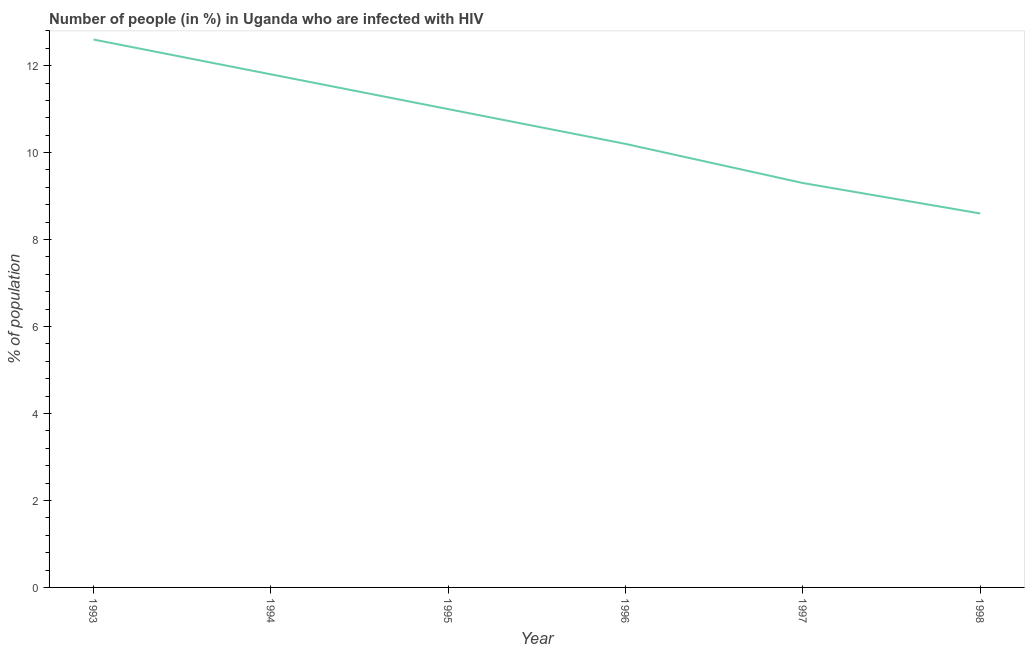What is the number of people infected with hiv in 1993?
Provide a succinct answer. 12.6. In which year was the number of people infected with hiv minimum?
Your response must be concise. 1998. What is the sum of the number of people infected with hiv?
Your answer should be very brief. 63.5. What is the average number of people infected with hiv per year?
Give a very brief answer. 10.58. In how many years, is the number of people infected with hiv greater than 2.8 %?
Your answer should be compact. 6. What is the ratio of the number of people infected with hiv in 1994 to that in 1995?
Keep it short and to the point. 1.07. Is the difference between the number of people infected with hiv in 1994 and 1997 greater than the difference between any two years?
Give a very brief answer. No. What is the difference between the highest and the second highest number of people infected with hiv?
Provide a short and direct response. 0.8. What is the difference between the highest and the lowest number of people infected with hiv?
Keep it short and to the point. 4. Does the number of people infected with hiv monotonically increase over the years?
Offer a terse response. No. How many years are there in the graph?
Your response must be concise. 6. What is the difference between two consecutive major ticks on the Y-axis?
Provide a succinct answer. 2. What is the title of the graph?
Offer a terse response. Number of people (in %) in Uganda who are infected with HIV. What is the label or title of the Y-axis?
Keep it short and to the point. % of population. What is the % of population of 1994?
Provide a succinct answer. 11.8. What is the % of population of 1997?
Keep it short and to the point. 9.3. What is the % of population of 1998?
Keep it short and to the point. 8.6. What is the difference between the % of population in 1993 and 1994?
Provide a short and direct response. 0.8. What is the difference between the % of population in 1993 and 1995?
Offer a terse response. 1.6. What is the difference between the % of population in 1994 and 1996?
Ensure brevity in your answer.  1.6. What is the ratio of the % of population in 1993 to that in 1994?
Keep it short and to the point. 1.07. What is the ratio of the % of population in 1993 to that in 1995?
Offer a very short reply. 1.15. What is the ratio of the % of population in 1993 to that in 1996?
Make the answer very short. 1.24. What is the ratio of the % of population in 1993 to that in 1997?
Your answer should be very brief. 1.35. What is the ratio of the % of population in 1993 to that in 1998?
Provide a short and direct response. 1.47. What is the ratio of the % of population in 1994 to that in 1995?
Offer a very short reply. 1.07. What is the ratio of the % of population in 1994 to that in 1996?
Your answer should be compact. 1.16. What is the ratio of the % of population in 1994 to that in 1997?
Your response must be concise. 1.27. What is the ratio of the % of population in 1994 to that in 1998?
Ensure brevity in your answer.  1.37. What is the ratio of the % of population in 1995 to that in 1996?
Your answer should be compact. 1.08. What is the ratio of the % of population in 1995 to that in 1997?
Keep it short and to the point. 1.18. What is the ratio of the % of population in 1995 to that in 1998?
Provide a short and direct response. 1.28. What is the ratio of the % of population in 1996 to that in 1997?
Provide a short and direct response. 1.1. What is the ratio of the % of population in 1996 to that in 1998?
Offer a terse response. 1.19. What is the ratio of the % of population in 1997 to that in 1998?
Ensure brevity in your answer.  1.08. 